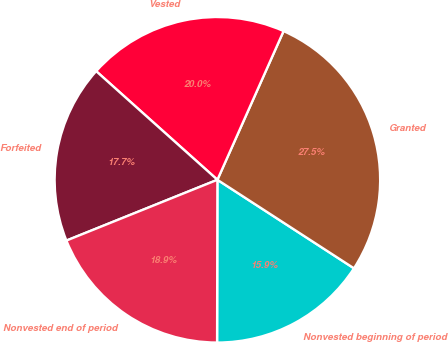Convert chart. <chart><loc_0><loc_0><loc_500><loc_500><pie_chart><fcel>Nonvested beginning of period<fcel>Granted<fcel>Vested<fcel>Forfeited<fcel>Nonvested end of period<nl><fcel>15.88%<fcel>27.49%<fcel>20.04%<fcel>17.72%<fcel>18.88%<nl></chart> 